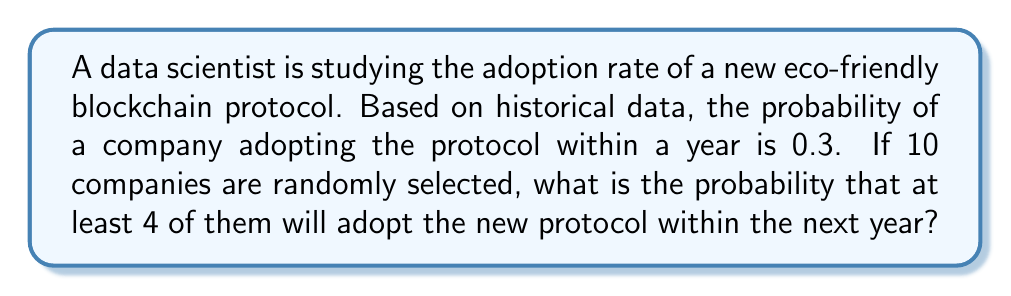Provide a solution to this math problem. To solve this problem, we can use the binomial probability distribution, as we have a fixed number of independent trials (10 companies) with a constant probability of success (0.3) for each trial.

Let X be the number of companies adopting the protocol. We want to find P(X ≥ 4).

The probability mass function for a binomial distribution is:

$$ P(X = k) = \binom{n}{k} p^k (1-p)^{n-k} $$

Where:
n = number of trials (10 companies)
k = number of successes
p = probability of success (0.3)

We need to calculate:

$$ P(X \geq 4) = 1 - P(X < 4) = 1 - [P(X = 0) + P(X = 1) + P(X = 2) + P(X = 3)] $$

Let's calculate each probability:

$$ P(X = 0) = \binom{10}{0} (0.3)^0 (0.7)^{10} = 0.0282 $$
$$ P(X = 1) = \binom{10}{1} (0.3)^1 (0.7)^9 = 0.1211 $$
$$ P(X = 2) = \binom{10}{2} (0.3)^2 (0.7)^8 = 0.2335 $$
$$ P(X = 3) = \binom{10}{3} (0.3)^3 (0.7)^7 = 0.2668 $$

Now, we can sum these probabilities and subtract from 1:

$$ P(X \geq 4) = 1 - (0.0282 + 0.1211 + 0.2335 + 0.2668) $$
$$ P(X \geq 4) = 1 - 0.6496 = 0.3504 $$

Therefore, the probability that at least 4 out of 10 randomly selected companies will adopt the new eco-friendly blockchain protocol within the next year is approximately 0.3504 or 35.04%.
Answer: 0.3504 or 35.04% 